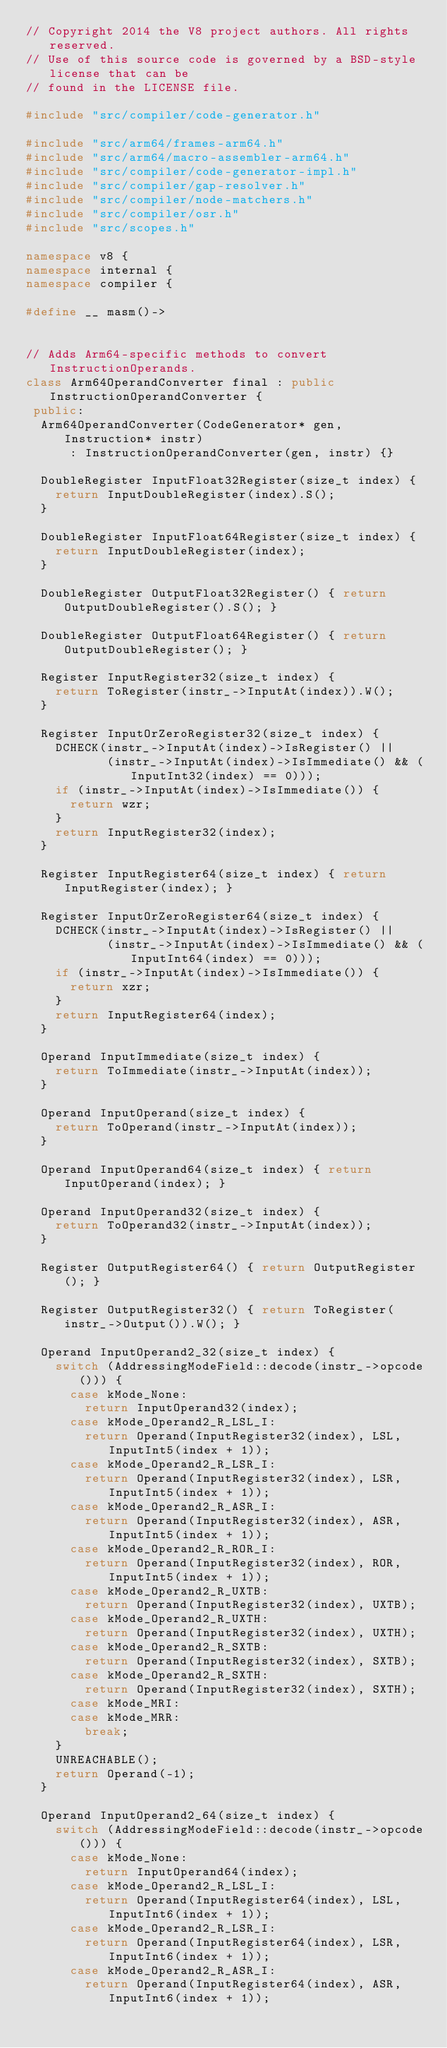<code> <loc_0><loc_0><loc_500><loc_500><_C++_>// Copyright 2014 the V8 project authors. All rights reserved.
// Use of this source code is governed by a BSD-style license that can be
// found in the LICENSE file.

#include "src/compiler/code-generator.h"

#include "src/arm64/frames-arm64.h"
#include "src/arm64/macro-assembler-arm64.h"
#include "src/compiler/code-generator-impl.h"
#include "src/compiler/gap-resolver.h"
#include "src/compiler/node-matchers.h"
#include "src/compiler/osr.h"
#include "src/scopes.h"

namespace v8 {
namespace internal {
namespace compiler {

#define __ masm()->


// Adds Arm64-specific methods to convert InstructionOperands.
class Arm64OperandConverter final : public InstructionOperandConverter {
 public:
  Arm64OperandConverter(CodeGenerator* gen, Instruction* instr)
      : InstructionOperandConverter(gen, instr) {}

  DoubleRegister InputFloat32Register(size_t index) {
    return InputDoubleRegister(index).S();
  }

  DoubleRegister InputFloat64Register(size_t index) {
    return InputDoubleRegister(index);
  }

  DoubleRegister OutputFloat32Register() { return OutputDoubleRegister().S(); }

  DoubleRegister OutputFloat64Register() { return OutputDoubleRegister(); }

  Register InputRegister32(size_t index) {
    return ToRegister(instr_->InputAt(index)).W();
  }

  Register InputOrZeroRegister32(size_t index) {
    DCHECK(instr_->InputAt(index)->IsRegister() ||
           (instr_->InputAt(index)->IsImmediate() && (InputInt32(index) == 0)));
    if (instr_->InputAt(index)->IsImmediate()) {
      return wzr;
    }
    return InputRegister32(index);
  }

  Register InputRegister64(size_t index) { return InputRegister(index); }

  Register InputOrZeroRegister64(size_t index) {
    DCHECK(instr_->InputAt(index)->IsRegister() ||
           (instr_->InputAt(index)->IsImmediate() && (InputInt64(index) == 0)));
    if (instr_->InputAt(index)->IsImmediate()) {
      return xzr;
    }
    return InputRegister64(index);
  }

  Operand InputImmediate(size_t index) {
    return ToImmediate(instr_->InputAt(index));
  }

  Operand InputOperand(size_t index) {
    return ToOperand(instr_->InputAt(index));
  }

  Operand InputOperand64(size_t index) { return InputOperand(index); }

  Operand InputOperand32(size_t index) {
    return ToOperand32(instr_->InputAt(index));
  }

  Register OutputRegister64() { return OutputRegister(); }

  Register OutputRegister32() { return ToRegister(instr_->Output()).W(); }

  Operand InputOperand2_32(size_t index) {
    switch (AddressingModeField::decode(instr_->opcode())) {
      case kMode_None:
        return InputOperand32(index);
      case kMode_Operand2_R_LSL_I:
        return Operand(InputRegister32(index), LSL, InputInt5(index + 1));
      case kMode_Operand2_R_LSR_I:
        return Operand(InputRegister32(index), LSR, InputInt5(index + 1));
      case kMode_Operand2_R_ASR_I:
        return Operand(InputRegister32(index), ASR, InputInt5(index + 1));
      case kMode_Operand2_R_ROR_I:
        return Operand(InputRegister32(index), ROR, InputInt5(index + 1));
      case kMode_Operand2_R_UXTB:
        return Operand(InputRegister32(index), UXTB);
      case kMode_Operand2_R_UXTH:
        return Operand(InputRegister32(index), UXTH);
      case kMode_Operand2_R_SXTB:
        return Operand(InputRegister32(index), SXTB);
      case kMode_Operand2_R_SXTH:
        return Operand(InputRegister32(index), SXTH);
      case kMode_MRI:
      case kMode_MRR:
        break;
    }
    UNREACHABLE();
    return Operand(-1);
  }

  Operand InputOperand2_64(size_t index) {
    switch (AddressingModeField::decode(instr_->opcode())) {
      case kMode_None:
        return InputOperand64(index);
      case kMode_Operand2_R_LSL_I:
        return Operand(InputRegister64(index), LSL, InputInt6(index + 1));
      case kMode_Operand2_R_LSR_I:
        return Operand(InputRegister64(index), LSR, InputInt6(index + 1));
      case kMode_Operand2_R_ASR_I:
        return Operand(InputRegister64(index), ASR, InputInt6(index + 1));</code> 